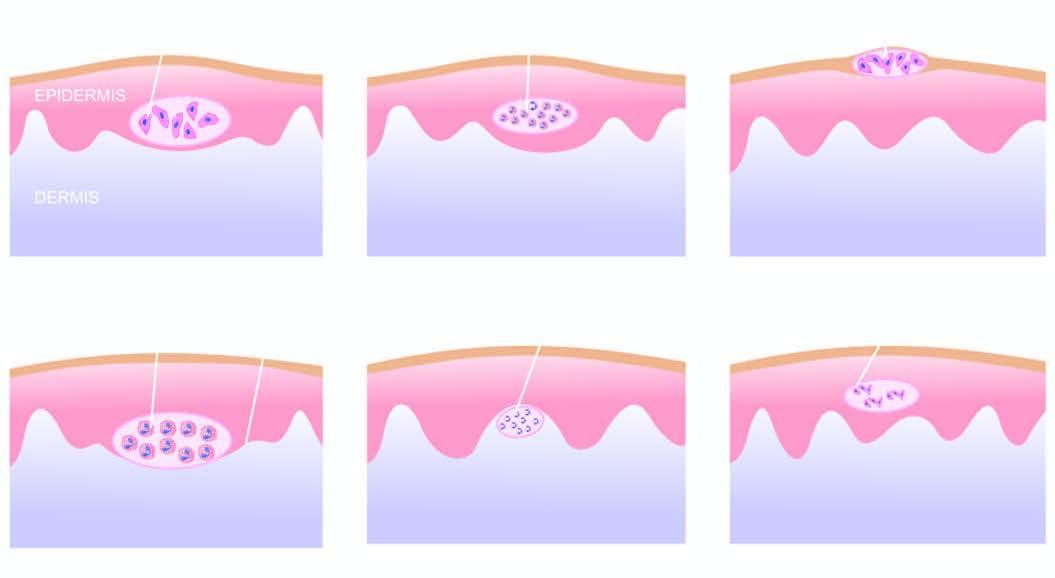what is subepidermal with regeneration of the epidermis at the periphery?
Answer the question using a single word or phrase. Bulla containing eosinophilis 